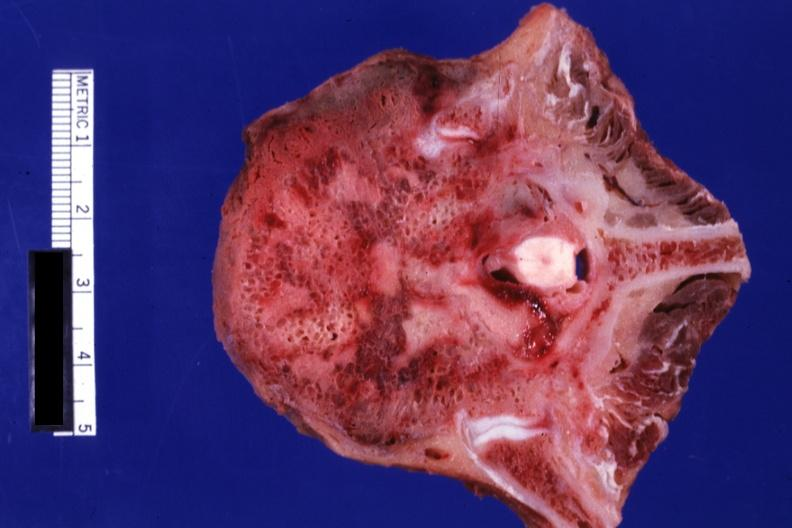what does this image show?
Answer the question using a single word or phrase. Close-up view excellent primary in mediastinum 